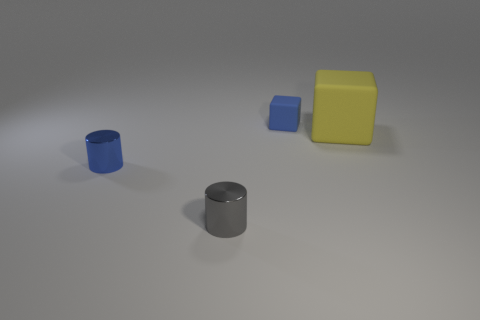Add 1 objects. How many objects exist? 5 Subtract 0 blue spheres. How many objects are left? 4 Subtract all yellow metallic blocks. Subtract all matte blocks. How many objects are left? 2 Add 1 metal cylinders. How many metal cylinders are left? 3 Add 3 blue metallic things. How many blue metallic things exist? 4 